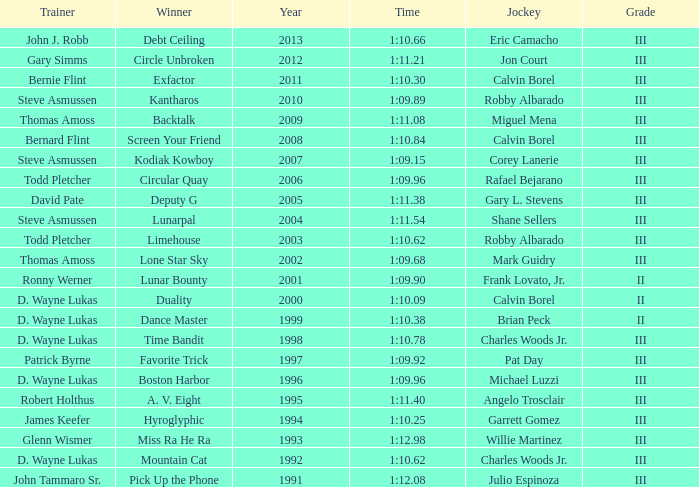Which trainer won the hyroglyphic in a year that was before 2010? James Keefer. 